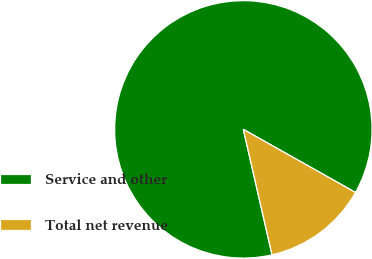<chart> <loc_0><loc_0><loc_500><loc_500><pie_chart><fcel>Service and other<fcel>Total net revenue<nl><fcel>86.74%<fcel>13.26%<nl></chart> 